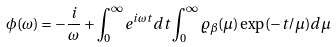Convert formula to latex. <formula><loc_0><loc_0><loc_500><loc_500>\phi ( \omega ) = - \frac { i } { \omega } + \int _ { 0 } ^ { \infty } e ^ { i \omega t } d t \int _ { 0 } ^ { \infty } \varrho _ { \beta } ( \mu ) \exp ( - t / \mu ) d \mu</formula> 